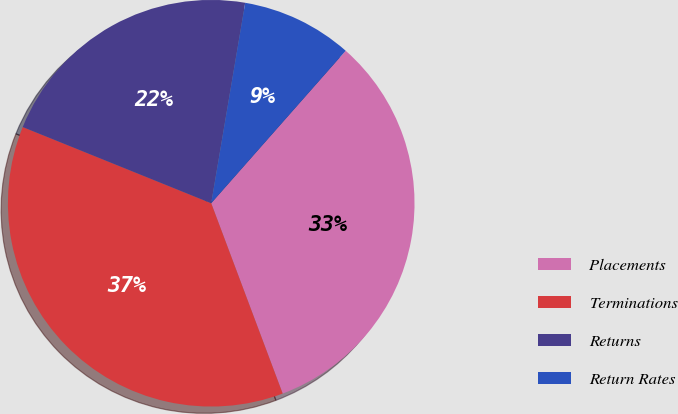Convert chart to OTSL. <chart><loc_0><loc_0><loc_500><loc_500><pie_chart><fcel>Placements<fcel>Terminations<fcel>Returns<fcel>Return Rates<nl><fcel>32.78%<fcel>36.83%<fcel>21.56%<fcel>8.83%<nl></chart> 